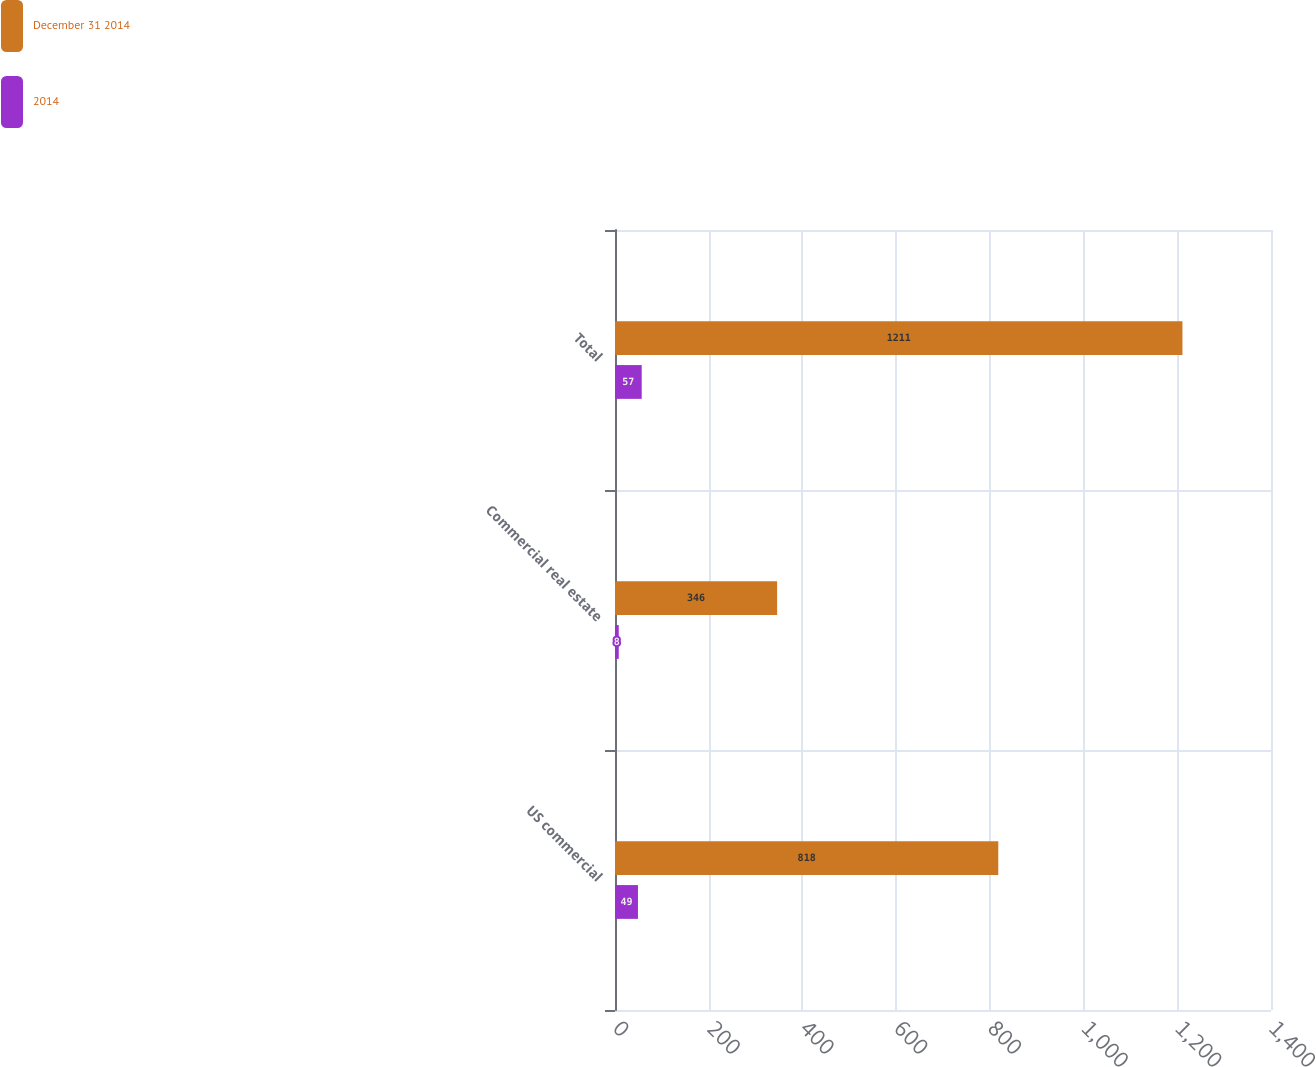<chart> <loc_0><loc_0><loc_500><loc_500><stacked_bar_chart><ecel><fcel>US commercial<fcel>Commercial real estate<fcel>Total<nl><fcel>December 31 2014<fcel>818<fcel>346<fcel>1211<nl><fcel>2014<fcel>49<fcel>8<fcel>57<nl></chart> 